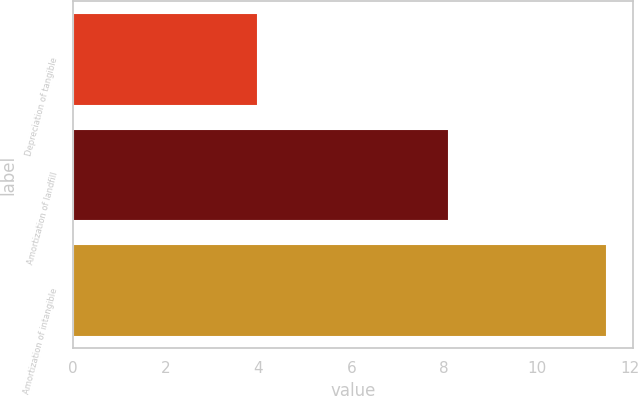Convert chart. <chart><loc_0><loc_0><loc_500><loc_500><bar_chart><fcel>Depreciation of tangible<fcel>Amortization of landfill<fcel>Amortization of intangible<nl><fcel>4<fcel>8.1<fcel>11.5<nl></chart> 